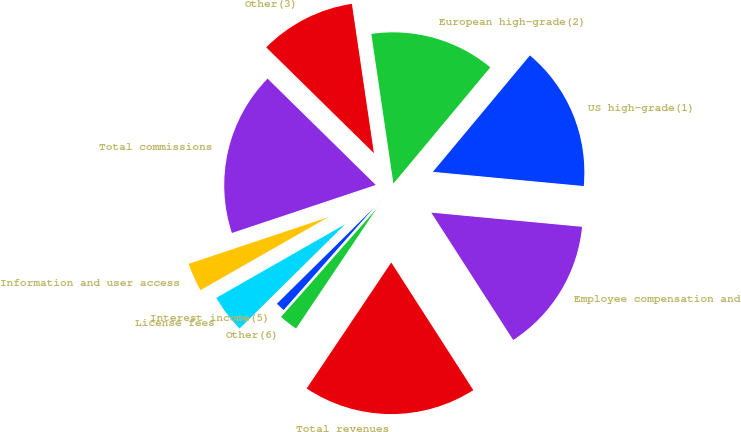Convert chart. <chart><loc_0><loc_0><loc_500><loc_500><pie_chart><fcel>US high-grade(1)<fcel>European high-grade(2)<fcel>Other(3)<fcel>Total commissions<fcel>Information and user access<fcel>License fees<fcel>Interest income(5)<fcel>Other(6)<fcel>Total revenues<fcel>Employee compensation and<nl><fcel>15.44%<fcel>13.39%<fcel>10.31%<fcel>17.49%<fcel>3.13%<fcel>4.15%<fcel>1.08%<fcel>2.1%<fcel>18.51%<fcel>14.41%<nl></chart> 